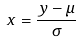Convert formula to latex. <formula><loc_0><loc_0><loc_500><loc_500>x = \frac { y - \mu } { \sigma }</formula> 